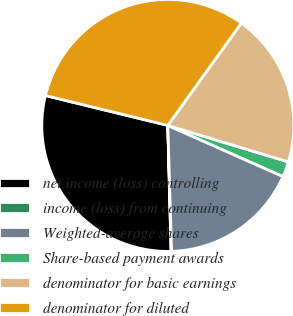Convert chart. <chart><loc_0><loc_0><loc_500><loc_500><pie_chart><fcel>net income (loss) controlling<fcel>income (loss) from continuing<fcel>Weighted-average shares<fcel>Share-based payment awards<fcel>denominator for basic earnings<fcel>denominator for diluted<nl><fcel>29.22%<fcel>0.07%<fcel>17.88%<fcel>1.96%<fcel>19.77%<fcel>31.11%<nl></chart> 